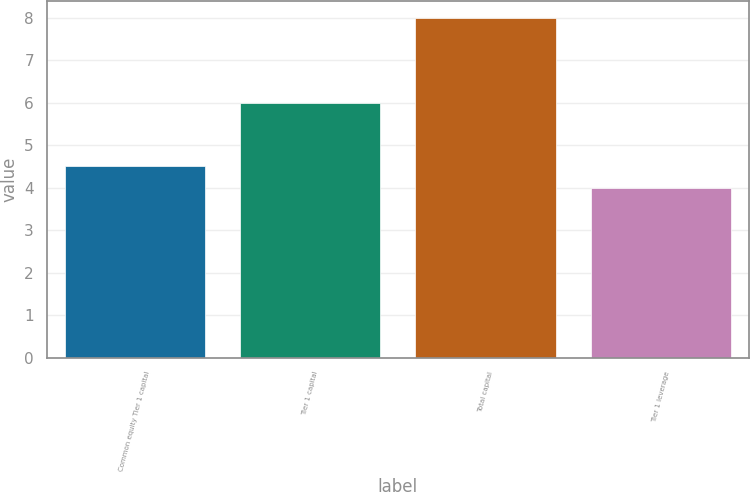<chart> <loc_0><loc_0><loc_500><loc_500><bar_chart><fcel>Common equity Tier 1 capital<fcel>Tier 1 capital<fcel>Total capital<fcel>Tier 1 leverage<nl><fcel>4.5<fcel>6<fcel>8<fcel>4<nl></chart> 